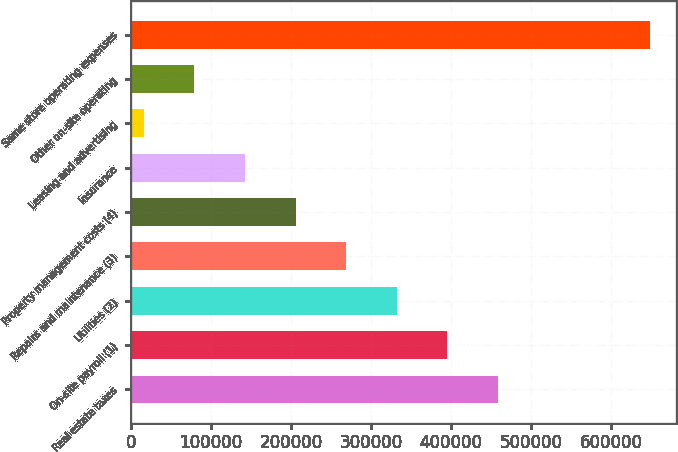Convert chart. <chart><loc_0><loc_0><loc_500><loc_500><bar_chart><fcel>Real estate taxes<fcel>On-site payroll (1)<fcel>Utilities (2)<fcel>Repairs and maintenance (3)<fcel>Property management costs (4)<fcel>Insurance<fcel>Leasing and advertising<fcel>Other on-site operating<fcel>Same store operating expenses<nl><fcel>458764<fcel>395516<fcel>332268<fcel>269021<fcel>205773<fcel>142525<fcel>16029<fcel>79276.9<fcel>648508<nl></chart> 